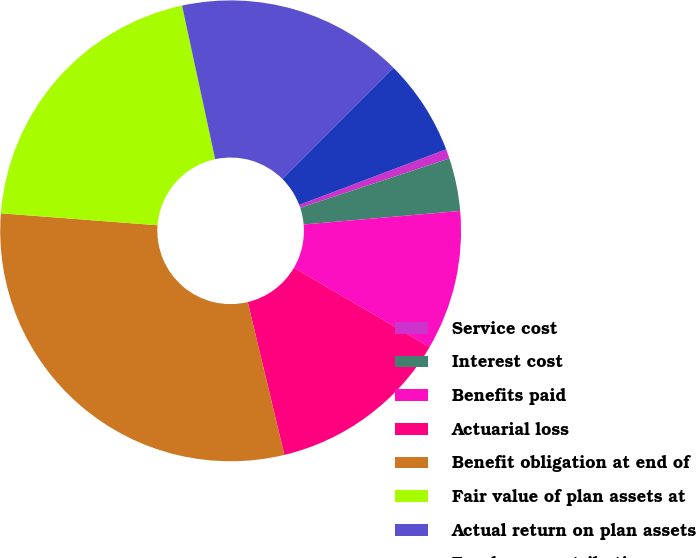<chart> <loc_0><loc_0><loc_500><loc_500><pie_chart><fcel>Service cost<fcel>Interest cost<fcel>Benefits paid<fcel>Actuarial loss<fcel>Benefit obligation at end of<fcel>Fair value of plan assets at<fcel>Actual return on plan assets<fcel>Employer contributions<nl><fcel>0.67%<fcel>3.71%<fcel>9.79%<fcel>12.84%<fcel>29.96%<fcel>20.41%<fcel>15.88%<fcel>6.75%<nl></chart> 